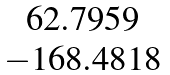<formula> <loc_0><loc_0><loc_500><loc_500>\begin{matrix} 6 2 . 7 9 5 9 \\ - 1 6 8 . 4 8 1 8 \end{matrix}</formula> 